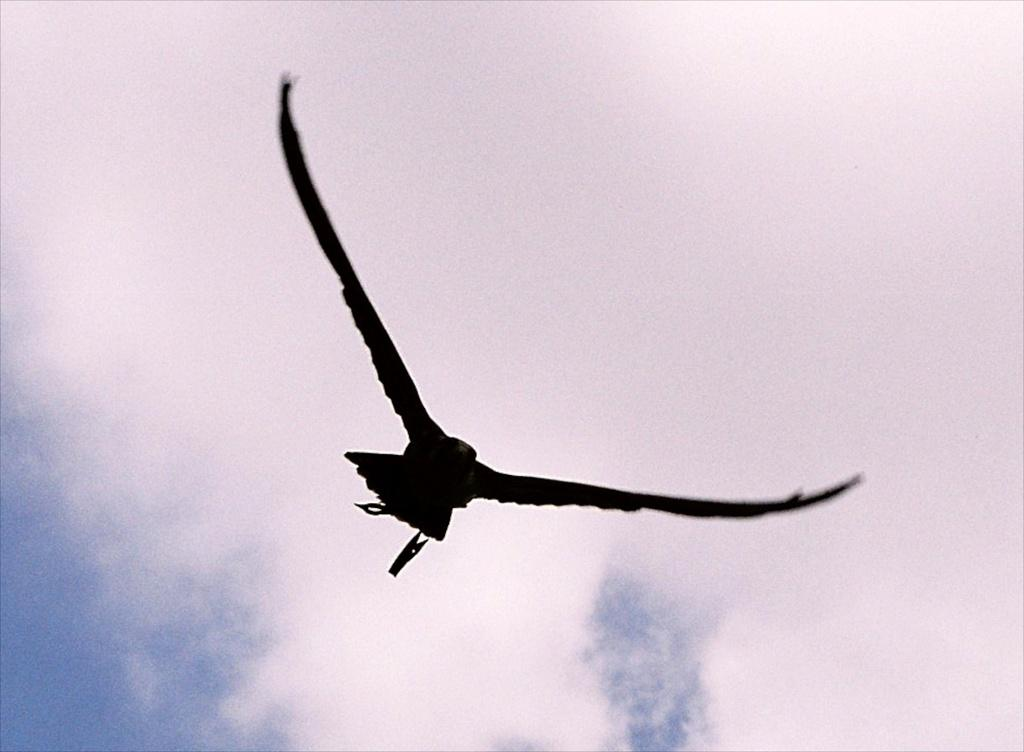What type of animal can be seen in the image? There is a bird in the image. What is the bird doing in the image? The bird is flying in the air. What can be seen in the background of the image? There is sky visible in the background of the image. What else is present in the sky? Clouds are present in the sky. What type of haircut does the bird have in the image? The bird does not have a haircut, as birds do not have hair. 